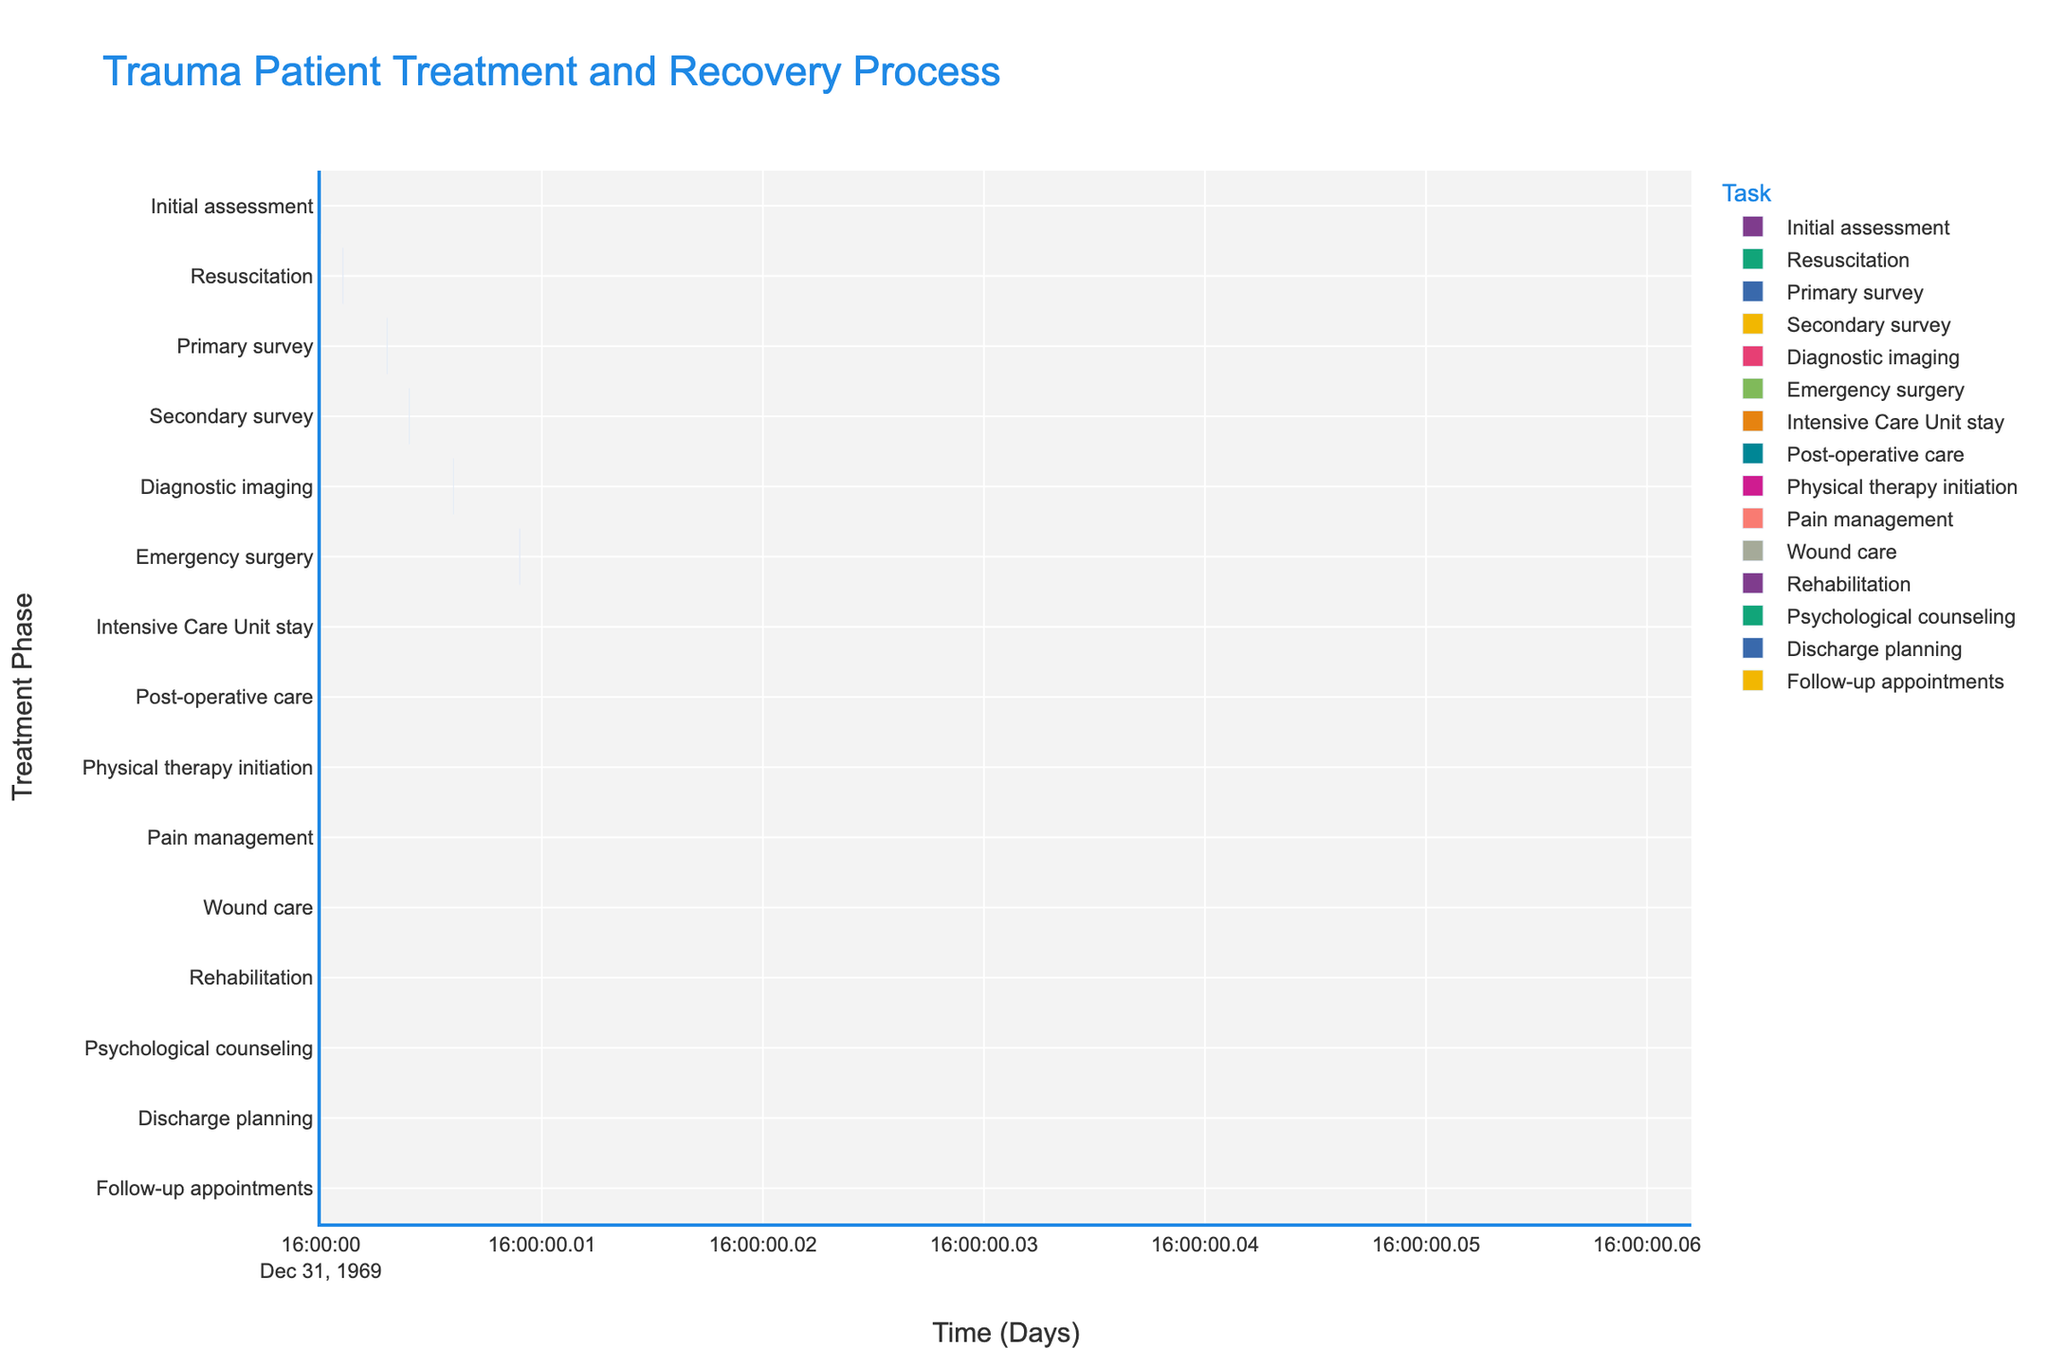What is the title of the Gantt chart? The title is displayed at the top of the chart, which provides a quick summary of the chart content.
Answer: "Trauma Patient Treatment and Recovery Process" What is the duration of the Intensive Care Unit stay phase? The duration can be found by locating the 'Intensive Care Unit stay' task on the y-axis and referring to its corresponding bar width along the x-axis which indicates the duration in days.
Answer: 7 days When does the Secondary survey phase end? By looking at the Secondary survey task on the y-axis and following its bar to the x-axis, you can see that it ends at Day 6.
Answer: Day 6 Which phase lasts the longest in the treatment and recovery process? To determine the longest phase, compare the widths of all bars on the x-axis; the longest bar represents Rehabilitation, lasting 10 days.
Answer: Rehabilitation What phases follow the Diagnostic imaging phase? Follow the x-axis from Diagnostic imaging (which ends at Day 9) and identify the subsequent phases: Emergency surgery, Intensive Care Unit stay, etc.
Answer: Emergency surgery How many phases are completed before Physical therapy initiation starts? Physical therapy initiation starts on Day 26. Count all bars ending before this day: Initial assessment, Resuscitation, Primary survey, Secondary survey, Diagnostic imaging, Emergency surgery, and Intensive Care Unit stay.
Answer: 7 phases Compare the duration of Emergency surgery and Post-operative care. Which one is longer? Check the bar lengths on the x-axis: Emergency surgery lasts 5 days, while Post-operative care also lasts 5 days. Both have the same duration.
Answer: Both are 5 days What's the total duration from the start of the treatment process to the end of the Discharge planning phase? Calculate the end day of Discharge planning, which is at Day 52. This duration includes all phases up to and including Discharge planning.
Answer: 52 days What is the difference in duration between Pain management and Wound care? Pain management lasts 4 days, and Wound care lasts 3 days. The difference between them is 4 - 3 = 1 day.
Answer: 1 day Which phase starts immediately after Post-operative care ends? Follow Post-operative care's end at Day 26; the next phase starting on the same day is Physical therapy initiation.
Answer: Physical therapy initiation 